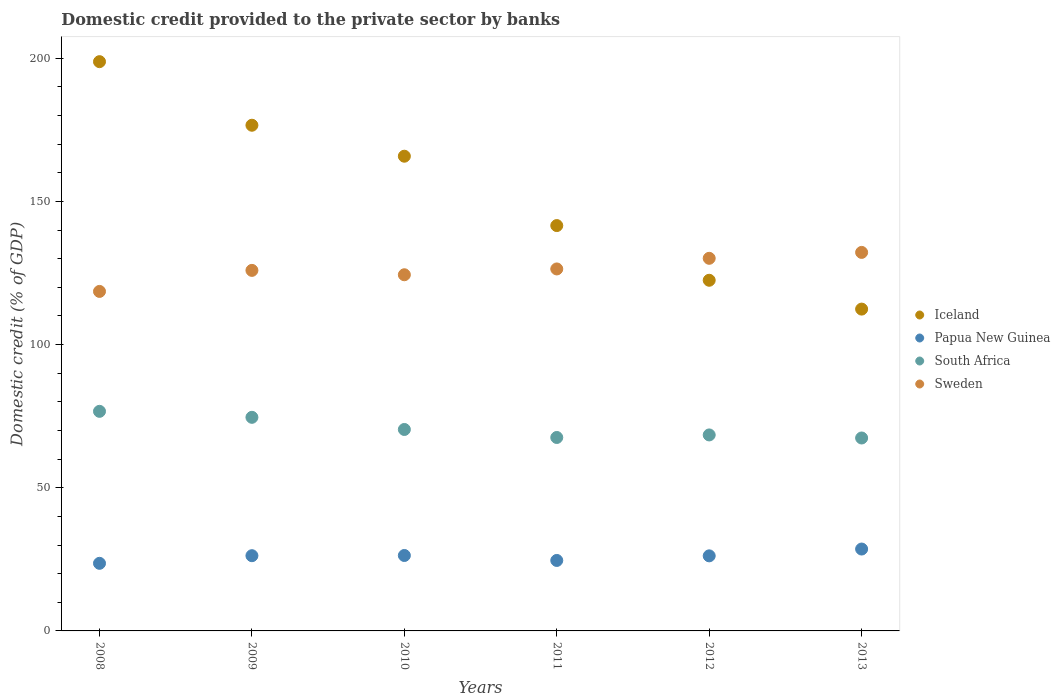How many different coloured dotlines are there?
Ensure brevity in your answer.  4. What is the domestic credit provided to the private sector by banks in Papua New Guinea in 2010?
Your answer should be very brief. 26.34. Across all years, what is the maximum domestic credit provided to the private sector by banks in Sweden?
Offer a very short reply. 132.19. Across all years, what is the minimum domestic credit provided to the private sector by banks in Papua New Guinea?
Provide a succinct answer. 23.61. In which year was the domestic credit provided to the private sector by banks in Iceland maximum?
Provide a short and direct response. 2008. What is the total domestic credit provided to the private sector by banks in Papua New Guinea in the graph?
Keep it short and to the point. 155.65. What is the difference between the domestic credit provided to the private sector by banks in South Africa in 2010 and that in 2013?
Keep it short and to the point. 2.97. What is the difference between the domestic credit provided to the private sector by banks in Papua New Guinea in 2012 and the domestic credit provided to the private sector by banks in South Africa in 2010?
Give a very brief answer. -44.14. What is the average domestic credit provided to the private sector by banks in Papua New Guinea per year?
Give a very brief answer. 25.94. In the year 2010, what is the difference between the domestic credit provided to the private sector by banks in Sweden and domestic credit provided to the private sector by banks in South Africa?
Your answer should be compact. 54.03. What is the ratio of the domestic credit provided to the private sector by banks in Iceland in 2012 to that in 2013?
Provide a short and direct response. 1.09. Is the domestic credit provided to the private sector by banks in Iceland in 2010 less than that in 2012?
Offer a very short reply. No. Is the difference between the domestic credit provided to the private sector by banks in Sweden in 2008 and 2009 greater than the difference between the domestic credit provided to the private sector by banks in South Africa in 2008 and 2009?
Offer a terse response. No. What is the difference between the highest and the second highest domestic credit provided to the private sector by banks in Sweden?
Your response must be concise. 2.06. What is the difference between the highest and the lowest domestic credit provided to the private sector by banks in Sweden?
Offer a very short reply. 13.62. In how many years, is the domestic credit provided to the private sector by banks in Papua New Guinea greater than the average domestic credit provided to the private sector by banks in Papua New Guinea taken over all years?
Offer a terse response. 4. Is it the case that in every year, the sum of the domestic credit provided to the private sector by banks in Papua New Guinea and domestic credit provided to the private sector by banks in Iceland  is greater than the sum of domestic credit provided to the private sector by banks in South Africa and domestic credit provided to the private sector by banks in Sweden?
Your answer should be compact. No. Does the domestic credit provided to the private sector by banks in Iceland monotonically increase over the years?
Provide a short and direct response. No. Is the domestic credit provided to the private sector by banks in South Africa strictly greater than the domestic credit provided to the private sector by banks in Iceland over the years?
Provide a short and direct response. No. Is the domestic credit provided to the private sector by banks in South Africa strictly less than the domestic credit provided to the private sector by banks in Sweden over the years?
Your answer should be compact. Yes. How many dotlines are there?
Offer a terse response. 4. How many years are there in the graph?
Give a very brief answer. 6. Does the graph contain any zero values?
Offer a very short reply. No. Does the graph contain grids?
Offer a terse response. No. Where does the legend appear in the graph?
Provide a short and direct response. Center right. How many legend labels are there?
Provide a short and direct response. 4. How are the legend labels stacked?
Provide a short and direct response. Vertical. What is the title of the graph?
Your response must be concise. Domestic credit provided to the private sector by banks. What is the label or title of the X-axis?
Your answer should be compact. Years. What is the label or title of the Y-axis?
Offer a terse response. Domestic credit (% of GDP). What is the Domestic credit (% of GDP) of Iceland in 2008?
Make the answer very short. 198.81. What is the Domestic credit (% of GDP) of Papua New Guinea in 2008?
Ensure brevity in your answer.  23.61. What is the Domestic credit (% of GDP) of South Africa in 2008?
Your answer should be very brief. 76.69. What is the Domestic credit (% of GDP) in Sweden in 2008?
Ensure brevity in your answer.  118.57. What is the Domestic credit (% of GDP) in Iceland in 2009?
Your answer should be very brief. 176.6. What is the Domestic credit (% of GDP) of Papua New Guinea in 2009?
Your answer should be very brief. 26.27. What is the Domestic credit (% of GDP) in South Africa in 2009?
Offer a very short reply. 74.6. What is the Domestic credit (% of GDP) of Sweden in 2009?
Your answer should be very brief. 125.91. What is the Domestic credit (% of GDP) in Iceland in 2010?
Give a very brief answer. 165.78. What is the Domestic credit (% of GDP) of Papua New Guinea in 2010?
Ensure brevity in your answer.  26.34. What is the Domestic credit (% of GDP) of South Africa in 2010?
Offer a very short reply. 70.35. What is the Domestic credit (% of GDP) of Sweden in 2010?
Your answer should be compact. 124.38. What is the Domestic credit (% of GDP) of Iceland in 2011?
Your answer should be compact. 141.56. What is the Domestic credit (% of GDP) in Papua New Guinea in 2011?
Your response must be concise. 24.61. What is the Domestic credit (% of GDP) of South Africa in 2011?
Offer a very short reply. 67.56. What is the Domestic credit (% of GDP) of Sweden in 2011?
Your response must be concise. 126.41. What is the Domestic credit (% of GDP) in Iceland in 2012?
Offer a terse response. 122.46. What is the Domestic credit (% of GDP) of Papua New Guinea in 2012?
Keep it short and to the point. 26.22. What is the Domestic credit (% of GDP) in South Africa in 2012?
Keep it short and to the point. 68.45. What is the Domestic credit (% of GDP) of Sweden in 2012?
Give a very brief answer. 130.13. What is the Domestic credit (% of GDP) of Iceland in 2013?
Offer a very short reply. 112.39. What is the Domestic credit (% of GDP) in Papua New Guinea in 2013?
Make the answer very short. 28.6. What is the Domestic credit (% of GDP) in South Africa in 2013?
Keep it short and to the point. 67.38. What is the Domestic credit (% of GDP) of Sweden in 2013?
Keep it short and to the point. 132.19. Across all years, what is the maximum Domestic credit (% of GDP) of Iceland?
Offer a very short reply. 198.81. Across all years, what is the maximum Domestic credit (% of GDP) of Papua New Guinea?
Ensure brevity in your answer.  28.6. Across all years, what is the maximum Domestic credit (% of GDP) of South Africa?
Your answer should be compact. 76.69. Across all years, what is the maximum Domestic credit (% of GDP) in Sweden?
Offer a very short reply. 132.19. Across all years, what is the minimum Domestic credit (% of GDP) in Iceland?
Ensure brevity in your answer.  112.39. Across all years, what is the minimum Domestic credit (% of GDP) in Papua New Guinea?
Provide a short and direct response. 23.61. Across all years, what is the minimum Domestic credit (% of GDP) in South Africa?
Give a very brief answer. 67.38. Across all years, what is the minimum Domestic credit (% of GDP) in Sweden?
Provide a short and direct response. 118.57. What is the total Domestic credit (% of GDP) of Iceland in the graph?
Your response must be concise. 917.61. What is the total Domestic credit (% of GDP) in Papua New Guinea in the graph?
Make the answer very short. 155.65. What is the total Domestic credit (% of GDP) in South Africa in the graph?
Your answer should be compact. 425.02. What is the total Domestic credit (% of GDP) in Sweden in the graph?
Provide a short and direct response. 757.6. What is the difference between the Domestic credit (% of GDP) of Iceland in 2008 and that in 2009?
Offer a terse response. 22.2. What is the difference between the Domestic credit (% of GDP) in Papua New Guinea in 2008 and that in 2009?
Offer a terse response. -2.66. What is the difference between the Domestic credit (% of GDP) in South Africa in 2008 and that in 2009?
Ensure brevity in your answer.  2.09. What is the difference between the Domestic credit (% of GDP) of Sweden in 2008 and that in 2009?
Your answer should be very brief. -7.35. What is the difference between the Domestic credit (% of GDP) of Iceland in 2008 and that in 2010?
Your answer should be compact. 33.02. What is the difference between the Domestic credit (% of GDP) of Papua New Guinea in 2008 and that in 2010?
Offer a very short reply. -2.74. What is the difference between the Domestic credit (% of GDP) in South Africa in 2008 and that in 2010?
Make the answer very short. 6.33. What is the difference between the Domestic credit (% of GDP) in Sweden in 2008 and that in 2010?
Your response must be concise. -5.82. What is the difference between the Domestic credit (% of GDP) in Iceland in 2008 and that in 2011?
Your answer should be very brief. 57.25. What is the difference between the Domestic credit (% of GDP) of Papua New Guinea in 2008 and that in 2011?
Provide a short and direct response. -1. What is the difference between the Domestic credit (% of GDP) of South Africa in 2008 and that in 2011?
Offer a terse response. 9.13. What is the difference between the Domestic credit (% of GDP) of Sweden in 2008 and that in 2011?
Your answer should be very brief. -7.85. What is the difference between the Domestic credit (% of GDP) of Iceland in 2008 and that in 2012?
Offer a terse response. 76.35. What is the difference between the Domestic credit (% of GDP) in Papua New Guinea in 2008 and that in 2012?
Keep it short and to the point. -2.61. What is the difference between the Domestic credit (% of GDP) of South Africa in 2008 and that in 2012?
Ensure brevity in your answer.  8.24. What is the difference between the Domestic credit (% of GDP) in Sweden in 2008 and that in 2012?
Your answer should be compact. -11.56. What is the difference between the Domestic credit (% of GDP) in Iceland in 2008 and that in 2013?
Ensure brevity in your answer.  86.41. What is the difference between the Domestic credit (% of GDP) of Papua New Guinea in 2008 and that in 2013?
Offer a terse response. -4.99. What is the difference between the Domestic credit (% of GDP) in South Africa in 2008 and that in 2013?
Provide a short and direct response. 9.31. What is the difference between the Domestic credit (% of GDP) in Sweden in 2008 and that in 2013?
Offer a terse response. -13.62. What is the difference between the Domestic credit (% of GDP) of Iceland in 2009 and that in 2010?
Offer a terse response. 10.82. What is the difference between the Domestic credit (% of GDP) in Papua New Guinea in 2009 and that in 2010?
Provide a short and direct response. -0.07. What is the difference between the Domestic credit (% of GDP) in South Africa in 2009 and that in 2010?
Provide a short and direct response. 4.24. What is the difference between the Domestic credit (% of GDP) of Sweden in 2009 and that in 2010?
Make the answer very short. 1.53. What is the difference between the Domestic credit (% of GDP) of Iceland in 2009 and that in 2011?
Ensure brevity in your answer.  35.04. What is the difference between the Domestic credit (% of GDP) of Papua New Guinea in 2009 and that in 2011?
Give a very brief answer. 1.66. What is the difference between the Domestic credit (% of GDP) of South Africa in 2009 and that in 2011?
Your answer should be compact. 7.04. What is the difference between the Domestic credit (% of GDP) of Sweden in 2009 and that in 2011?
Ensure brevity in your answer.  -0.5. What is the difference between the Domestic credit (% of GDP) in Iceland in 2009 and that in 2012?
Provide a succinct answer. 54.14. What is the difference between the Domestic credit (% of GDP) in Papua New Guinea in 2009 and that in 2012?
Offer a terse response. 0.06. What is the difference between the Domestic credit (% of GDP) of South Africa in 2009 and that in 2012?
Keep it short and to the point. 6.15. What is the difference between the Domestic credit (% of GDP) in Sweden in 2009 and that in 2012?
Provide a short and direct response. -4.22. What is the difference between the Domestic credit (% of GDP) in Iceland in 2009 and that in 2013?
Your answer should be compact. 64.21. What is the difference between the Domestic credit (% of GDP) in Papua New Guinea in 2009 and that in 2013?
Offer a terse response. -2.32. What is the difference between the Domestic credit (% of GDP) in South Africa in 2009 and that in 2013?
Your answer should be compact. 7.22. What is the difference between the Domestic credit (% of GDP) in Sweden in 2009 and that in 2013?
Your response must be concise. -6.28. What is the difference between the Domestic credit (% of GDP) of Iceland in 2010 and that in 2011?
Keep it short and to the point. 24.22. What is the difference between the Domestic credit (% of GDP) in Papua New Guinea in 2010 and that in 2011?
Your response must be concise. 1.73. What is the difference between the Domestic credit (% of GDP) in South Africa in 2010 and that in 2011?
Make the answer very short. 2.8. What is the difference between the Domestic credit (% of GDP) of Sweden in 2010 and that in 2011?
Provide a short and direct response. -2.03. What is the difference between the Domestic credit (% of GDP) of Iceland in 2010 and that in 2012?
Offer a terse response. 43.32. What is the difference between the Domestic credit (% of GDP) of Papua New Guinea in 2010 and that in 2012?
Offer a terse response. 0.13. What is the difference between the Domestic credit (% of GDP) in South Africa in 2010 and that in 2012?
Offer a very short reply. 1.91. What is the difference between the Domestic credit (% of GDP) of Sweden in 2010 and that in 2012?
Give a very brief answer. -5.74. What is the difference between the Domestic credit (% of GDP) of Iceland in 2010 and that in 2013?
Ensure brevity in your answer.  53.39. What is the difference between the Domestic credit (% of GDP) of Papua New Guinea in 2010 and that in 2013?
Make the answer very short. -2.25. What is the difference between the Domestic credit (% of GDP) of South Africa in 2010 and that in 2013?
Provide a succinct answer. 2.97. What is the difference between the Domestic credit (% of GDP) in Sweden in 2010 and that in 2013?
Your answer should be very brief. -7.81. What is the difference between the Domestic credit (% of GDP) of Iceland in 2011 and that in 2012?
Provide a succinct answer. 19.1. What is the difference between the Domestic credit (% of GDP) of Papua New Guinea in 2011 and that in 2012?
Give a very brief answer. -1.6. What is the difference between the Domestic credit (% of GDP) in South Africa in 2011 and that in 2012?
Your answer should be compact. -0.89. What is the difference between the Domestic credit (% of GDP) of Sweden in 2011 and that in 2012?
Your answer should be very brief. -3.71. What is the difference between the Domestic credit (% of GDP) in Iceland in 2011 and that in 2013?
Offer a very short reply. 29.17. What is the difference between the Domestic credit (% of GDP) in Papua New Guinea in 2011 and that in 2013?
Your answer should be very brief. -3.98. What is the difference between the Domestic credit (% of GDP) in South Africa in 2011 and that in 2013?
Your answer should be very brief. 0.18. What is the difference between the Domestic credit (% of GDP) of Sweden in 2011 and that in 2013?
Give a very brief answer. -5.78. What is the difference between the Domestic credit (% of GDP) of Iceland in 2012 and that in 2013?
Provide a short and direct response. 10.07. What is the difference between the Domestic credit (% of GDP) of Papua New Guinea in 2012 and that in 2013?
Make the answer very short. -2.38. What is the difference between the Domestic credit (% of GDP) of South Africa in 2012 and that in 2013?
Your answer should be compact. 1.07. What is the difference between the Domestic credit (% of GDP) in Sweden in 2012 and that in 2013?
Your answer should be compact. -2.06. What is the difference between the Domestic credit (% of GDP) of Iceland in 2008 and the Domestic credit (% of GDP) of Papua New Guinea in 2009?
Keep it short and to the point. 172.53. What is the difference between the Domestic credit (% of GDP) of Iceland in 2008 and the Domestic credit (% of GDP) of South Africa in 2009?
Your answer should be compact. 124.21. What is the difference between the Domestic credit (% of GDP) in Iceland in 2008 and the Domestic credit (% of GDP) in Sweden in 2009?
Your response must be concise. 72.89. What is the difference between the Domestic credit (% of GDP) of Papua New Guinea in 2008 and the Domestic credit (% of GDP) of South Africa in 2009?
Your answer should be compact. -50.99. What is the difference between the Domestic credit (% of GDP) in Papua New Guinea in 2008 and the Domestic credit (% of GDP) in Sweden in 2009?
Offer a very short reply. -102.31. What is the difference between the Domestic credit (% of GDP) in South Africa in 2008 and the Domestic credit (% of GDP) in Sweden in 2009?
Give a very brief answer. -49.23. What is the difference between the Domestic credit (% of GDP) of Iceland in 2008 and the Domestic credit (% of GDP) of Papua New Guinea in 2010?
Offer a very short reply. 172.46. What is the difference between the Domestic credit (% of GDP) of Iceland in 2008 and the Domestic credit (% of GDP) of South Africa in 2010?
Offer a terse response. 128.45. What is the difference between the Domestic credit (% of GDP) of Iceland in 2008 and the Domestic credit (% of GDP) of Sweden in 2010?
Your response must be concise. 74.42. What is the difference between the Domestic credit (% of GDP) in Papua New Guinea in 2008 and the Domestic credit (% of GDP) in South Africa in 2010?
Provide a short and direct response. -46.74. What is the difference between the Domestic credit (% of GDP) in Papua New Guinea in 2008 and the Domestic credit (% of GDP) in Sweden in 2010?
Provide a short and direct response. -100.78. What is the difference between the Domestic credit (% of GDP) of South Africa in 2008 and the Domestic credit (% of GDP) of Sweden in 2010?
Provide a short and direct response. -47.7. What is the difference between the Domestic credit (% of GDP) in Iceland in 2008 and the Domestic credit (% of GDP) in Papua New Guinea in 2011?
Your response must be concise. 174.19. What is the difference between the Domestic credit (% of GDP) in Iceland in 2008 and the Domestic credit (% of GDP) in South Africa in 2011?
Ensure brevity in your answer.  131.25. What is the difference between the Domestic credit (% of GDP) of Iceland in 2008 and the Domestic credit (% of GDP) of Sweden in 2011?
Offer a terse response. 72.39. What is the difference between the Domestic credit (% of GDP) in Papua New Guinea in 2008 and the Domestic credit (% of GDP) in South Africa in 2011?
Provide a succinct answer. -43.95. What is the difference between the Domestic credit (% of GDP) in Papua New Guinea in 2008 and the Domestic credit (% of GDP) in Sweden in 2011?
Provide a succinct answer. -102.81. What is the difference between the Domestic credit (% of GDP) in South Africa in 2008 and the Domestic credit (% of GDP) in Sweden in 2011?
Keep it short and to the point. -49.73. What is the difference between the Domestic credit (% of GDP) of Iceland in 2008 and the Domestic credit (% of GDP) of Papua New Guinea in 2012?
Ensure brevity in your answer.  172.59. What is the difference between the Domestic credit (% of GDP) of Iceland in 2008 and the Domestic credit (% of GDP) of South Africa in 2012?
Provide a succinct answer. 130.36. What is the difference between the Domestic credit (% of GDP) of Iceland in 2008 and the Domestic credit (% of GDP) of Sweden in 2012?
Ensure brevity in your answer.  68.68. What is the difference between the Domestic credit (% of GDP) in Papua New Guinea in 2008 and the Domestic credit (% of GDP) in South Africa in 2012?
Offer a terse response. -44.84. What is the difference between the Domestic credit (% of GDP) in Papua New Guinea in 2008 and the Domestic credit (% of GDP) in Sweden in 2012?
Ensure brevity in your answer.  -106.52. What is the difference between the Domestic credit (% of GDP) in South Africa in 2008 and the Domestic credit (% of GDP) in Sweden in 2012?
Keep it short and to the point. -53.44. What is the difference between the Domestic credit (% of GDP) in Iceland in 2008 and the Domestic credit (% of GDP) in Papua New Guinea in 2013?
Offer a terse response. 170.21. What is the difference between the Domestic credit (% of GDP) in Iceland in 2008 and the Domestic credit (% of GDP) in South Africa in 2013?
Offer a terse response. 131.43. What is the difference between the Domestic credit (% of GDP) in Iceland in 2008 and the Domestic credit (% of GDP) in Sweden in 2013?
Provide a succinct answer. 66.62. What is the difference between the Domestic credit (% of GDP) in Papua New Guinea in 2008 and the Domestic credit (% of GDP) in South Africa in 2013?
Offer a very short reply. -43.77. What is the difference between the Domestic credit (% of GDP) of Papua New Guinea in 2008 and the Domestic credit (% of GDP) of Sweden in 2013?
Your answer should be compact. -108.58. What is the difference between the Domestic credit (% of GDP) of South Africa in 2008 and the Domestic credit (% of GDP) of Sweden in 2013?
Provide a succinct answer. -55.5. What is the difference between the Domestic credit (% of GDP) in Iceland in 2009 and the Domestic credit (% of GDP) in Papua New Guinea in 2010?
Provide a succinct answer. 150.26. What is the difference between the Domestic credit (% of GDP) in Iceland in 2009 and the Domestic credit (% of GDP) in South Africa in 2010?
Offer a very short reply. 106.25. What is the difference between the Domestic credit (% of GDP) in Iceland in 2009 and the Domestic credit (% of GDP) in Sweden in 2010?
Your answer should be very brief. 52.22. What is the difference between the Domestic credit (% of GDP) of Papua New Guinea in 2009 and the Domestic credit (% of GDP) of South Africa in 2010?
Make the answer very short. -44.08. What is the difference between the Domestic credit (% of GDP) in Papua New Guinea in 2009 and the Domestic credit (% of GDP) in Sweden in 2010?
Ensure brevity in your answer.  -98.11. What is the difference between the Domestic credit (% of GDP) of South Africa in 2009 and the Domestic credit (% of GDP) of Sweden in 2010?
Your response must be concise. -49.79. What is the difference between the Domestic credit (% of GDP) of Iceland in 2009 and the Domestic credit (% of GDP) of Papua New Guinea in 2011?
Offer a terse response. 151.99. What is the difference between the Domestic credit (% of GDP) of Iceland in 2009 and the Domestic credit (% of GDP) of South Africa in 2011?
Your response must be concise. 109.05. What is the difference between the Domestic credit (% of GDP) of Iceland in 2009 and the Domestic credit (% of GDP) of Sweden in 2011?
Your response must be concise. 50.19. What is the difference between the Domestic credit (% of GDP) of Papua New Guinea in 2009 and the Domestic credit (% of GDP) of South Africa in 2011?
Your answer should be very brief. -41.28. What is the difference between the Domestic credit (% of GDP) in Papua New Guinea in 2009 and the Domestic credit (% of GDP) in Sweden in 2011?
Keep it short and to the point. -100.14. What is the difference between the Domestic credit (% of GDP) in South Africa in 2009 and the Domestic credit (% of GDP) in Sweden in 2011?
Make the answer very short. -51.82. What is the difference between the Domestic credit (% of GDP) in Iceland in 2009 and the Domestic credit (% of GDP) in Papua New Guinea in 2012?
Give a very brief answer. 150.39. What is the difference between the Domestic credit (% of GDP) of Iceland in 2009 and the Domestic credit (% of GDP) of South Africa in 2012?
Make the answer very short. 108.16. What is the difference between the Domestic credit (% of GDP) in Iceland in 2009 and the Domestic credit (% of GDP) in Sweden in 2012?
Your answer should be compact. 46.47. What is the difference between the Domestic credit (% of GDP) in Papua New Guinea in 2009 and the Domestic credit (% of GDP) in South Africa in 2012?
Ensure brevity in your answer.  -42.17. What is the difference between the Domestic credit (% of GDP) in Papua New Guinea in 2009 and the Domestic credit (% of GDP) in Sweden in 2012?
Your answer should be compact. -103.86. What is the difference between the Domestic credit (% of GDP) of South Africa in 2009 and the Domestic credit (% of GDP) of Sweden in 2012?
Ensure brevity in your answer.  -55.53. What is the difference between the Domestic credit (% of GDP) of Iceland in 2009 and the Domestic credit (% of GDP) of Papua New Guinea in 2013?
Your answer should be compact. 148.01. What is the difference between the Domestic credit (% of GDP) in Iceland in 2009 and the Domestic credit (% of GDP) in South Africa in 2013?
Give a very brief answer. 109.22. What is the difference between the Domestic credit (% of GDP) of Iceland in 2009 and the Domestic credit (% of GDP) of Sweden in 2013?
Provide a succinct answer. 44.41. What is the difference between the Domestic credit (% of GDP) in Papua New Guinea in 2009 and the Domestic credit (% of GDP) in South Africa in 2013?
Your answer should be very brief. -41.11. What is the difference between the Domestic credit (% of GDP) in Papua New Guinea in 2009 and the Domestic credit (% of GDP) in Sweden in 2013?
Your answer should be very brief. -105.92. What is the difference between the Domestic credit (% of GDP) in South Africa in 2009 and the Domestic credit (% of GDP) in Sweden in 2013?
Your response must be concise. -57.59. What is the difference between the Domestic credit (% of GDP) of Iceland in 2010 and the Domestic credit (% of GDP) of Papua New Guinea in 2011?
Ensure brevity in your answer.  141.17. What is the difference between the Domestic credit (% of GDP) in Iceland in 2010 and the Domestic credit (% of GDP) in South Africa in 2011?
Provide a succinct answer. 98.23. What is the difference between the Domestic credit (% of GDP) in Iceland in 2010 and the Domestic credit (% of GDP) in Sweden in 2011?
Your answer should be compact. 39.37. What is the difference between the Domestic credit (% of GDP) in Papua New Guinea in 2010 and the Domestic credit (% of GDP) in South Africa in 2011?
Provide a succinct answer. -41.21. What is the difference between the Domestic credit (% of GDP) in Papua New Guinea in 2010 and the Domestic credit (% of GDP) in Sweden in 2011?
Your answer should be compact. -100.07. What is the difference between the Domestic credit (% of GDP) in South Africa in 2010 and the Domestic credit (% of GDP) in Sweden in 2011?
Your response must be concise. -56.06. What is the difference between the Domestic credit (% of GDP) in Iceland in 2010 and the Domestic credit (% of GDP) in Papua New Guinea in 2012?
Provide a short and direct response. 139.57. What is the difference between the Domestic credit (% of GDP) in Iceland in 2010 and the Domestic credit (% of GDP) in South Africa in 2012?
Ensure brevity in your answer.  97.34. What is the difference between the Domestic credit (% of GDP) in Iceland in 2010 and the Domestic credit (% of GDP) in Sweden in 2012?
Ensure brevity in your answer.  35.66. What is the difference between the Domestic credit (% of GDP) in Papua New Guinea in 2010 and the Domestic credit (% of GDP) in South Africa in 2012?
Give a very brief answer. -42.1. What is the difference between the Domestic credit (% of GDP) of Papua New Guinea in 2010 and the Domestic credit (% of GDP) of Sweden in 2012?
Ensure brevity in your answer.  -103.79. What is the difference between the Domestic credit (% of GDP) in South Africa in 2010 and the Domestic credit (% of GDP) in Sweden in 2012?
Keep it short and to the point. -59.78. What is the difference between the Domestic credit (% of GDP) in Iceland in 2010 and the Domestic credit (% of GDP) in Papua New Guinea in 2013?
Your answer should be compact. 137.19. What is the difference between the Domestic credit (% of GDP) of Iceland in 2010 and the Domestic credit (% of GDP) of South Africa in 2013?
Offer a very short reply. 98.41. What is the difference between the Domestic credit (% of GDP) of Iceland in 2010 and the Domestic credit (% of GDP) of Sweden in 2013?
Your answer should be compact. 33.59. What is the difference between the Domestic credit (% of GDP) of Papua New Guinea in 2010 and the Domestic credit (% of GDP) of South Africa in 2013?
Keep it short and to the point. -41.04. What is the difference between the Domestic credit (% of GDP) of Papua New Guinea in 2010 and the Domestic credit (% of GDP) of Sweden in 2013?
Ensure brevity in your answer.  -105.85. What is the difference between the Domestic credit (% of GDP) of South Africa in 2010 and the Domestic credit (% of GDP) of Sweden in 2013?
Your response must be concise. -61.84. What is the difference between the Domestic credit (% of GDP) in Iceland in 2011 and the Domestic credit (% of GDP) in Papua New Guinea in 2012?
Offer a terse response. 115.34. What is the difference between the Domestic credit (% of GDP) of Iceland in 2011 and the Domestic credit (% of GDP) of South Africa in 2012?
Give a very brief answer. 73.11. What is the difference between the Domestic credit (% of GDP) of Iceland in 2011 and the Domestic credit (% of GDP) of Sweden in 2012?
Provide a succinct answer. 11.43. What is the difference between the Domestic credit (% of GDP) in Papua New Guinea in 2011 and the Domestic credit (% of GDP) in South Africa in 2012?
Keep it short and to the point. -43.83. What is the difference between the Domestic credit (% of GDP) in Papua New Guinea in 2011 and the Domestic credit (% of GDP) in Sweden in 2012?
Provide a succinct answer. -105.52. What is the difference between the Domestic credit (% of GDP) of South Africa in 2011 and the Domestic credit (% of GDP) of Sweden in 2012?
Ensure brevity in your answer.  -62.57. What is the difference between the Domestic credit (% of GDP) of Iceland in 2011 and the Domestic credit (% of GDP) of Papua New Guinea in 2013?
Offer a very short reply. 112.96. What is the difference between the Domestic credit (% of GDP) in Iceland in 2011 and the Domestic credit (% of GDP) in South Africa in 2013?
Provide a short and direct response. 74.18. What is the difference between the Domestic credit (% of GDP) of Iceland in 2011 and the Domestic credit (% of GDP) of Sweden in 2013?
Offer a terse response. 9.37. What is the difference between the Domestic credit (% of GDP) of Papua New Guinea in 2011 and the Domestic credit (% of GDP) of South Africa in 2013?
Your answer should be compact. -42.77. What is the difference between the Domestic credit (% of GDP) of Papua New Guinea in 2011 and the Domestic credit (% of GDP) of Sweden in 2013?
Make the answer very short. -107.58. What is the difference between the Domestic credit (% of GDP) of South Africa in 2011 and the Domestic credit (% of GDP) of Sweden in 2013?
Your answer should be very brief. -64.63. What is the difference between the Domestic credit (% of GDP) in Iceland in 2012 and the Domestic credit (% of GDP) in Papua New Guinea in 2013?
Provide a short and direct response. 93.86. What is the difference between the Domestic credit (% of GDP) in Iceland in 2012 and the Domestic credit (% of GDP) in South Africa in 2013?
Make the answer very short. 55.08. What is the difference between the Domestic credit (% of GDP) in Iceland in 2012 and the Domestic credit (% of GDP) in Sweden in 2013?
Provide a succinct answer. -9.73. What is the difference between the Domestic credit (% of GDP) of Papua New Guinea in 2012 and the Domestic credit (% of GDP) of South Africa in 2013?
Your answer should be very brief. -41.16. What is the difference between the Domestic credit (% of GDP) in Papua New Guinea in 2012 and the Domestic credit (% of GDP) in Sweden in 2013?
Keep it short and to the point. -105.97. What is the difference between the Domestic credit (% of GDP) of South Africa in 2012 and the Domestic credit (% of GDP) of Sweden in 2013?
Your answer should be very brief. -63.74. What is the average Domestic credit (% of GDP) in Iceland per year?
Provide a succinct answer. 152.93. What is the average Domestic credit (% of GDP) of Papua New Guinea per year?
Your response must be concise. 25.94. What is the average Domestic credit (% of GDP) in South Africa per year?
Ensure brevity in your answer.  70.84. What is the average Domestic credit (% of GDP) in Sweden per year?
Provide a short and direct response. 126.27. In the year 2008, what is the difference between the Domestic credit (% of GDP) in Iceland and Domestic credit (% of GDP) in Papua New Guinea?
Your response must be concise. 175.2. In the year 2008, what is the difference between the Domestic credit (% of GDP) in Iceland and Domestic credit (% of GDP) in South Africa?
Provide a short and direct response. 122.12. In the year 2008, what is the difference between the Domestic credit (% of GDP) of Iceland and Domestic credit (% of GDP) of Sweden?
Offer a terse response. 80.24. In the year 2008, what is the difference between the Domestic credit (% of GDP) of Papua New Guinea and Domestic credit (% of GDP) of South Africa?
Provide a short and direct response. -53.08. In the year 2008, what is the difference between the Domestic credit (% of GDP) in Papua New Guinea and Domestic credit (% of GDP) in Sweden?
Provide a short and direct response. -94.96. In the year 2008, what is the difference between the Domestic credit (% of GDP) of South Africa and Domestic credit (% of GDP) of Sweden?
Your answer should be compact. -41.88. In the year 2009, what is the difference between the Domestic credit (% of GDP) in Iceland and Domestic credit (% of GDP) in Papua New Guinea?
Make the answer very short. 150.33. In the year 2009, what is the difference between the Domestic credit (% of GDP) in Iceland and Domestic credit (% of GDP) in South Africa?
Give a very brief answer. 102.01. In the year 2009, what is the difference between the Domestic credit (% of GDP) in Iceland and Domestic credit (% of GDP) in Sweden?
Ensure brevity in your answer.  50.69. In the year 2009, what is the difference between the Domestic credit (% of GDP) of Papua New Guinea and Domestic credit (% of GDP) of South Africa?
Keep it short and to the point. -48.32. In the year 2009, what is the difference between the Domestic credit (% of GDP) in Papua New Guinea and Domestic credit (% of GDP) in Sweden?
Keep it short and to the point. -99.64. In the year 2009, what is the difference between the Domestic credit (% of GDP) in South Africa and Domestic credit (% of GDP) in Sweden?
Your answer should be very brief. -51.32. In the year 2010, what is the difference between the Domestic credit (% of GDP) of Iceland and Domestic credit (% of GDP) of Papua New Guinea?
Give a very brief answer. 139.44. In the year 2010, what is the difference between the Domestic credit (% of GDP) in Iceland and Domestic credit (% of GDP) in South Africa?
Your response must be concise. 95.43. In the year 2010, what is the difference between the Domestic credit (% of GDP) of Iceland and Domestic credit (% of GDP) of Sweden?
Ensure brevity in your answer.  41.4. In the year 2010, what is the difference between the Domestic credit (% of GDP) in Papua New Guinea and Domestic credit (% of GDP) in South Africa?
Your answer should be compact. -44.01. In the year 2010, what is the difference between the Domestic credit (% of GDP) of Papua New Guinea and Domestic credit (% of GDP) of Sweden?
Offer a terse response. -98.04. In the year 2010, what is the difference between the Domestic credit (% of GDP) of South Africa and Domestic credit (% of GDP) of Sweden?
Provide a short and direct response. -54.03. In the year 2011, what is the difference between the Domestic credit (% of GDP) in Iceland and Domestic credit (% of GDP) in Papua New Guinea?
Provide a succinct answer. 116.95. In the year 2011, what is the difference between the Domestic credit (% of GDP) in Iceland and Domestic credit (% of GDP) in South Africa?
Give a very brief answer. 74. In the year 2011, what is the difference between the Domestic credit (% of GDP) in Iceland and Domestic credit (% of GDP) in Sweden?
Make the answer very short. 15.15. In the year 2011, what is the difference between the Domestic credit (% of GDP) of Papua New Guinea and Domestic credit (% of GDP) of South Africa?
Your answer should be compact. -42.95. In the year 2011, what is the difference between the Domestic credit (% of GDP) of Papua New Guinea and Domestic credit (% of GDP) of Sweden?
Your answer should be compact. -101.8. In the year 2011, what is the difference between the Domestic credit (% of GDP) of South Africa and Domestic credit (% of GDP) of Sweden?
Your response must be concise. -58.86. In the year 2012, what is the difference between the Domestic credit (% of GDP) in Iceland and Domestic credit (% of GDP) in Papua New Guinea?
Offer a very short reply. 96.24. In the year 2012, what is the difference between the Domestic credit (% of GDP) of Iceland and Domestic credit (% of GDP) of South Africa?
Make the answer very short. 54.01. In the year 2012, what is the difference between the Domestic credit (% of GDP) of Iceland and Domestic credit (% of GDP) of Sweden?
Offer a very short reply. -7.67. In the year 2012, what is the difference between the Domestic credit (% of GDP) of Papua New Guinea and Domestic credit (% of GDP) of South Africa?
Offer a very short reply. -42.23. In the year 2012, what is the difference between the Domestic credit (% of GDP) in Papua New Guinea and Domestic credit (% of GDP) in Sweden?
Give a very brief answer. -103.91. In the year 2012, what is the difference between the Domestic credit (% of GDP) in South Africa and Domestic credit (% of GDP) in Sweden?
Your answer should be compact. -61.68. In the year 2013, what is the difference between the Domestic credit (% of GDP) in Iceland and Domestic credit (% of GDP) in Papua New Guinea?
Make the answer very short. 83.8. In the year 2013, what is the difference between the Domestic credit (% of GDP) in Iceland and Domestic credit (% of GDP) in South Africa?
Provide a short and direct response. 45.01. In the year 2013, what is the difference between the Domestic credit (% of GDP) in Iceland and Domestic credit (% of GDP) in Sweden?
Offer a very short reply. -19.8. In the year 2013, what is the difference between the Domestic credit (% of GDP) of Papua New Guinea and Domestic credit (% of GDP) of South Africa?
Your response must be concise. -38.78. In the year 2013, what is the difference between the Domestic credit (% of GDP) in Papua New Guinea and Domestic credit (% of GDP) in Sweden?
Ensure brevity in your answer.  -103.59. In the year 2013, what is the difference between the Domestic credit (% of GDP) in South Africa and Domestic credit (% of GDP) in Sweden?
Ensure brevity in your answer.  -64.81. What is the ratio of the Domestic credit (% of GDP) of Iceland in 2008 to that in 2009?
Provide a short and direct response. 1.13. What is the ratio of the Domestic credit (% of GDP) of Papua New Guinea in 2008 to that in 2009?
Keep it short and to the point. 0.9. What is the ratio of the Domestic credit (% of GDP) of South Africa in 2008 to that in 2009?
Offer a terse response. 1.03. What is the ratio of the Domestic credit (% of GDP) in Sweden in 2008 to that in 2009?
Provide a short and direct response. 0.94. What is the ratio of the Domestic credit (% of GDP) of Iceland in 2008 to that in 2010?
Your answer should be very brief. 1.2. What is the ratio of the Domestic credit (% of GDP) of Papua New Guinea in 2008 to that in 2010?
Offer a very short reply. 0.9. What is the ratio of the Domestic credit (% of GDP) of South Africa in 2008 to that in 2010?
Offer a very short reply. 1.09. What is the ratio of the Domestic credit (% of GDP) in Sweden in 2008 to that in 2010?
Your answer should be very brief. 0.95. What is the ratio of the Domestic credit (% of GDP) of Iceland in 2008 to that in 2011?
Provide a short and direct response. 1.4. What is the ratio of the Domestic credit (% of GDP) in Papua New Guinea in 2008 to that in 2011?
Your answer should be very brief. 0.96. What is the ratio of the Domestic credit (% of GDP) in South Africa in 2008 to that in 2011?
Make the answer very short. 1.14. What is the ratio of the Domestic credit (% of GDP) of Sweden in 2008 to that in 2011?
Keep it short and to the point. 0.94. What is the ratio of the Domestic credit (% of GDP) in Iceland in 2008 to that in 2012?
Offer a terse response. 1.62. What is the ratio of the Domestic credit (% of GDP) of Papua New Guinea in 2008 to that in 2012?
Ensure brevity in your answer.  0.9. What is the ratio of the Domestic credit (% of GDP) of South Africa in 2008 to that in 2012?
Keep it short and to the point. 1.12. What is the ratio of the Domestic credit (% of GDP) of Sweden in 2008 to that in 2012?
Provide a short and direct response. 0.91. What is the ratio of the Domestic credit (% of GDP) in Iceland in 2008 to that in 2013?
Make the answer very short. 1.77. What is the ratio of the Domestic credit (% of GDP) of Papua New Guinea in 2008 to that in 2013?
Your response must be concise. 0.83. What is the ratio of the Domestic credit (% of GDP) of South Africa in 2008 to that in 2013?
Ensure brevity in your answer.  1.14. What is the ratio of the Domestic credit (% of GDP) in Sweden in 2008 to that in 2013?
Offer a terse response. 0.9. What is the ratio of the Domestic credit (% of GDP) of Iceland in 2009 to that in 2010?
Make the answer very short. 1.07. What is the ratio of the Domestic credit (% of GDP) of Papua New Guinea in 2009 to that in 2010?
Provide a succinct answer. 1. What is the ratio of the Domestic credit (% of GDP) in South Africa in 2009 to that in 2010?
Keep it short and to the point. 1.06. What is the ratio of the Domestic credit (% of GDP) of Sweden in 2009 to that in 2010?
Provide a short and direct response. 1.01. What is the ratio of the Domestic credit (% of GDP) in Iceland in 2009 to that in 2011?
Make the answer very short. 1.25. What is the ratio of the Domestic credit (% of GDP) in Papua New Guinea in 2009 to that in 2011?
Give a very brief answer. 1.07. What is the ratio of the Domestic credit (% of GDP) of South Africa in 2009 to that in 2011?
Give a very brief answer. 1.1. What is the ratio of the Domestic credit (% of GDP) of Sweden in 2009 to that in 2011?
Provide a short and direct response. 1. What is the ratio of the Domestic credit (% of GDP) in Iceland in 2009 to that in 2012?
Give a very brief answer. 1.44. What is the ratio of the Domestic credit (% of GDP) in Papua New Guinea in 2009 to that in 2012?
Keep it short and to the point. 1. What is the ratio of the Domestic credit (% of GDP) in South Africa in 2009 to that in 2012?
Provide a short and direct response. 1.09. What is the ratio of the Domestic credit (% of GDP) of Sweden in 2009 to that in 2012?
Offer a very short reply. 0.97. What is the ratio of the Domestic credit (% of GDP) in Iceland in 2009 to that in 2013?
Give a very brief answer. 1.57. What is the ratio of the Domestic credit (% of GDP) of Papua New Guinea in 2009 to that in 2013?
Make the answer very short. 0.92. What is the ratio of the Domestic credit (% of GDP) in South Africa in 2009 to that in 2013?
Your answer should be very brief. 1.11. What is the ratio of the Domestic credit (% of GDP) in Sweden in 2009 to that in 2013?
Offer a terse response. 0.95. What is the ratio of the Domestic credit (% of GDP) of Iceland in 2010 to that in 2011?
Keep it short and to the point. 1.17. What is the ratio of the Domestic credit (% of GDP) in Papua New Guinea in 2010 to that in 2011?
Your response must be concise. 1.07. What is the ratio of the Domestic credit (% of GDP) of South Africa in 2010 to that in 2011?
Provide a short and direct response. 1.04. What is the ratio of the Domestic credit (% of GDP) in Sweden in 2010 to that in 2011?
Offer a very short reply. 0.98. What is the ratio of the Domestic credit (% of GDP) of Iceland in 2010 to that in 2012?
Your response must be concise. 1.35. What is the ratio of the Domestic credit (% of GDP) in South Africa in 2010 to that in 2012?
Offer a terse response. 1.03. What is the ratio of the Domestic credit (% of GDP) in Sweden in 2010 to that in 2012?
Make the answer very short. 0.96. What is the ratio of the Domestic credit (% of GDP) in Iceland in 2010 to that in 2013?
Make the answer very short. 1.48. What is the ratio of the Domestic credit (% of GDP) of Papua New Guinea in 2010 to that in 2013?
Your response must be concise. 0.92. What is the ratio of the Domestic credit (% of GDP) in South Africa in 2010 to that in 2013?
Provide a short and direct response. 1.04. What is the ratio of the Domestic credit (% of GDP) in Sweden in 2010 to that in 2013?
Keep it short and to the point. 0.94. What is the ratio of the Domestic credit (% of GDP) of Iceland in 2011 to that in 2012?
Your response must be concise. 1.16. What is the ratio of the Domestic credit (% of GDP) of Papua New Guinea in 2011 to that in 2012?
Provide a short and direct response. 0.94. What is the ratio of the Domestic credit (% of GDP) of Sweden in 2011 to that in 2012?
Give a very brief answer. 0.97. What is the ratio of the Domestic credit (% of GDP) of Iceland in 2011 to that in 2013?
Offer a very short reply. 1.26. What is the ratio of the Domestic credit (% of GDP) of Papua New Guinea in 2011 to that in 2013?
Offer a terse response. 0.86. What is the ratio of the Domestic credit (% of GDP) in South Africa in 2011 to that in 2013?
Give a very brief answer. 1. What is the ratio of the Domestic credit (% of GDP) of Sweden in 2011 to that in 2013?
Your answer should be compact. 0.96. What is the ratio of the Domestic credit (% of GDP) of Iceland in 2012 to that in 2013?
Provide a short and direct response. 1.09. What is the ratio of the Domestic credit (% of GDP) in Papua New Guinea in 2012 to that in 2013?
Offer a terse response. 0.92. What is the ratio of the Domestic credit (% of GDP) of South Africa in 2012 to that in 2013?
Your answer should be very brief. 1.02. What is the ratio of the Domestic credit (% of GDP) of Sweden in 2012 to that in 2013?
Give a very brief answer. 0.98. What is the difference between the highest and the second highest Domestic credit (% of GDP) in Iceland?
Provide a short and direct response. 22.2. What is the difference between the highest and the second highest Domestic credit (% of GDP) in Papua New Guinea?
Give a very brief answer. 2.25. What is the difference between the highest and the second highest Domestic credit (% of GDP) of South Africa?
Your response must be concise. 2.09. What is the difference between the highest and the second highest Domestic credit (% of GDP) in Sweden?
Offer a very short reply. 2.06. What is the difference between the highest and the lowest Domestic credit (% of GDP) in Iceland?
Your response must be concise. 86.41. What is the difference between the highest and the lowest Domestic credit (% of GDP) in Papua New Guinea?
Provide a short and direct response. 4.99. What is the difference between the highest and the lowest Domestic credit (% of GDP) of South Africa?
Provide a succinct answer. 9.31. What is the difference between the highest and the lowest Domestic credit (% of GDP) in Sweden?
Your answer should be very brief. 13.62. 